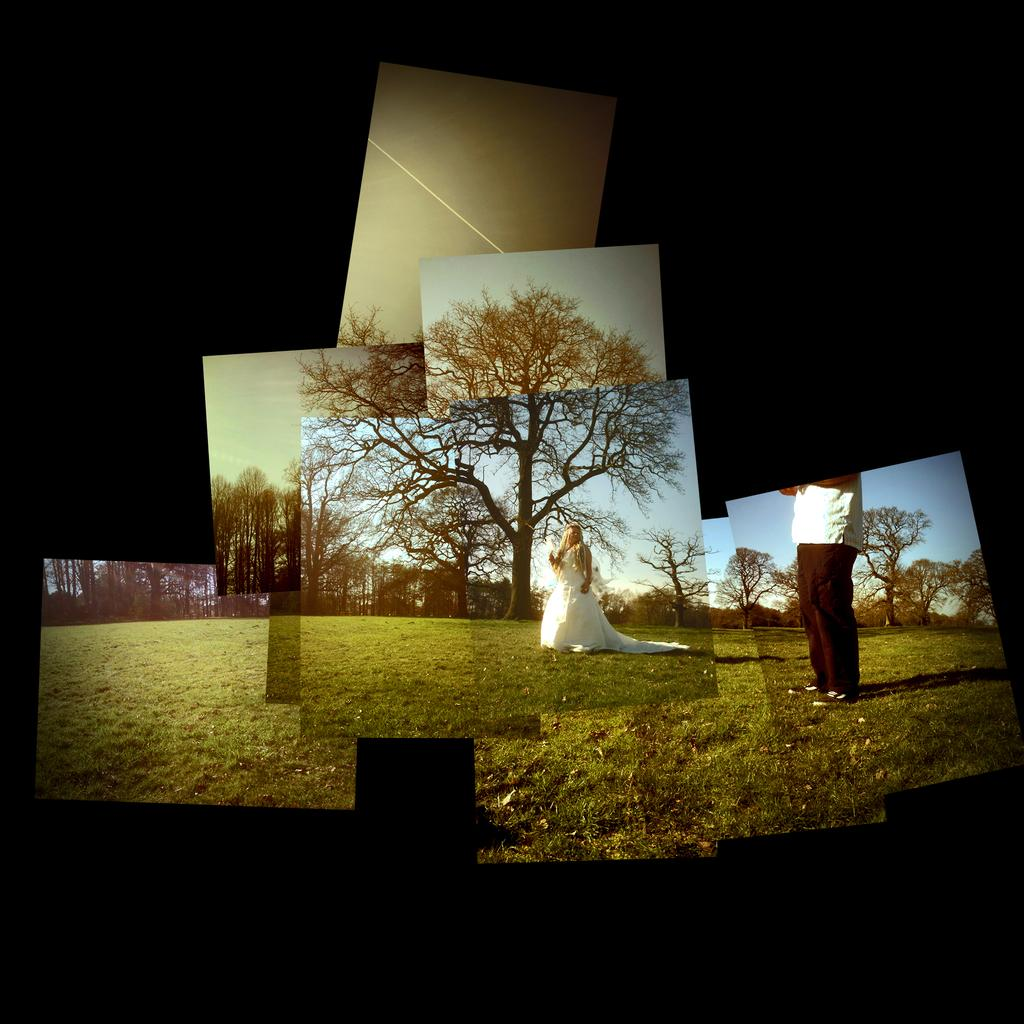What is the main subject of the image? There is a woman standing in the image. What is the color of the ground beneath the woman? The ground beneath the woman is green. Can you describe the person in the right corner of the image? There is a person standing in the right corner of the image. What can be seen in the background of the image? There are trees in the background of the image. What type of stick is the giraffe holding in the image? There is no giraffe or stick present in the image. How does the coach instruct the woman in the image? There is no coach present in the image, so it is not possible to answer how the coach instructs the woman. 